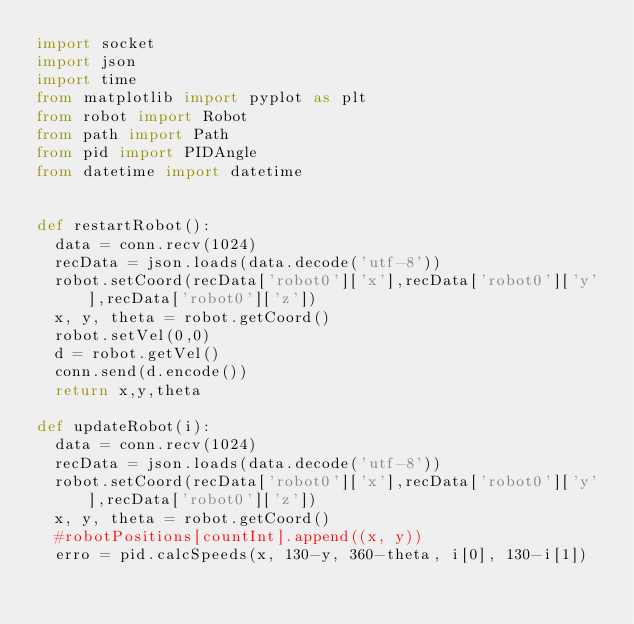<code> <loc_0><loc_0><loc_500><loc_500><_Python_>import socket
import json
import time
from matplotlib import pyplot as plt
from robot import Robot
from path import Path
from pid import PIDAngle
from datetime import datetime


def restartRobot():
	data = conn.recv(1024)
	recData = json.loads(data.decode('utf-8'))
	robot.setCoord(recData['robot0']['x'],recData['robot0']['y'],recData['robot0']['z'])
	x, y, theta = robot.getCoord()
	robot.setVel(0,0)
	d = robot.getVel()
	conn.send(d.encode())
	return x,y,theta

def updateRobot(i):
	data = conn.recv(1024)
	recData = json.loads(data.decode('utf-8'))
	robot.setCoord(recData['robot0']['x'],recData['robot0']['y'],recData['robot0']['z'])		
	x, y, theta = robot.getCoord()
	#robotPositions[countInt].append((x, y))
	erro = pid.calcSpeeds(x, 130-y, 360-theta, i[0], 130-i[1])</code> 